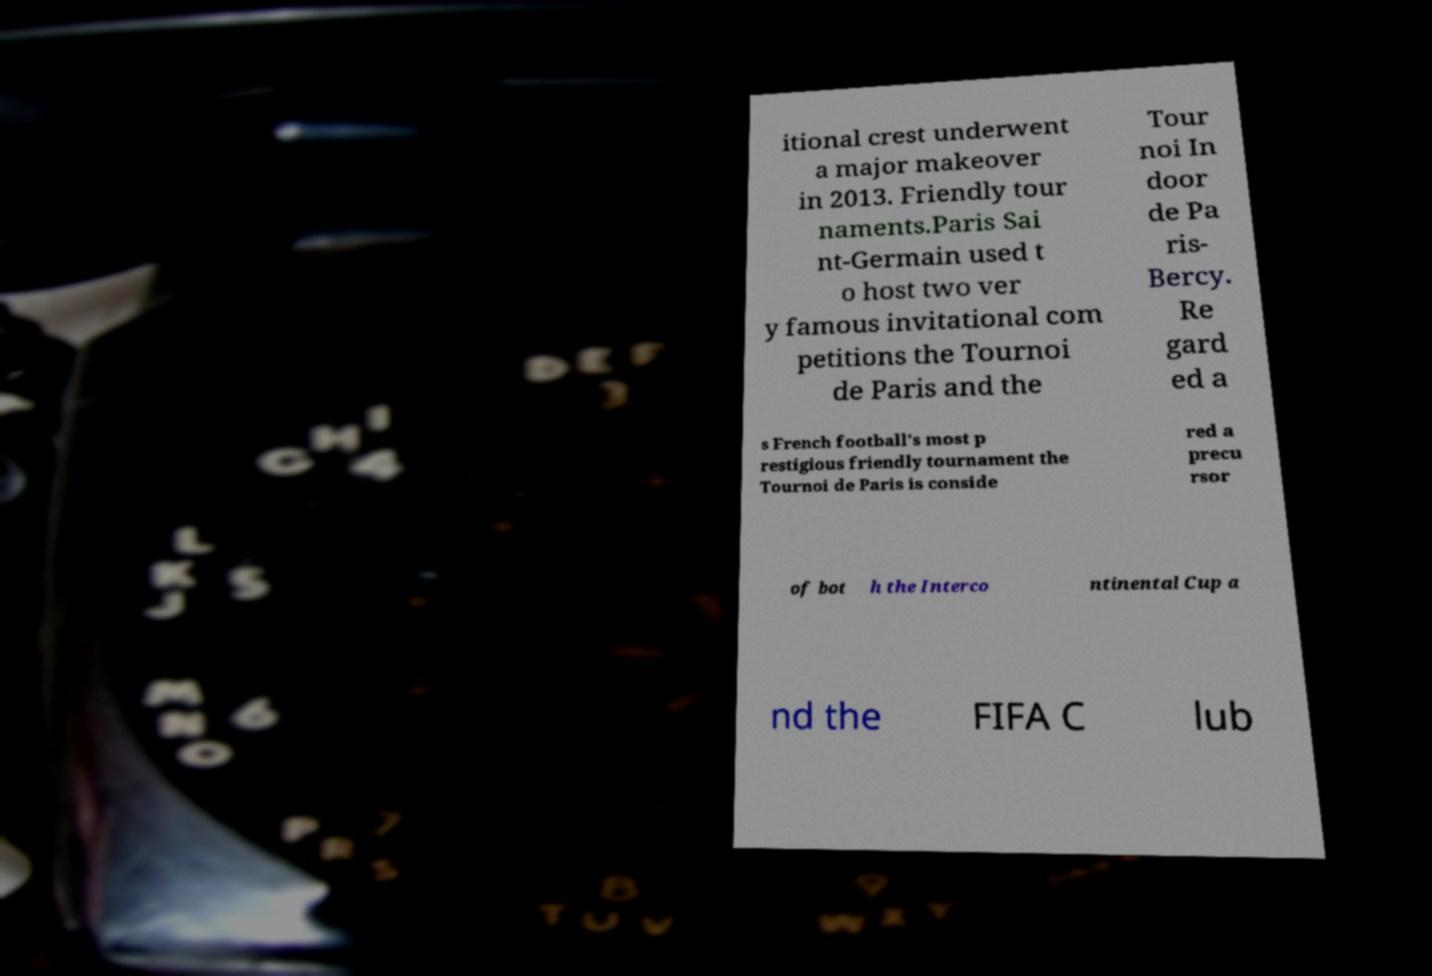Could you assist in decoding the text presented in this image and type it out clearly? itional crest underwent a major makeover in 2013. Friendly tour naments.Paris Sai nt-Germain used t o host two ver y famous invitational com petitions the Tournoi de Paris and the Tour noi In door de Pa ris- Bercy. Re gard ed a s French football's most p restigious friendly tournament the Tournoi de Paris is conside red a precu rsor of bot h the Interco ntinental Cup a nd the FIFA C lub 